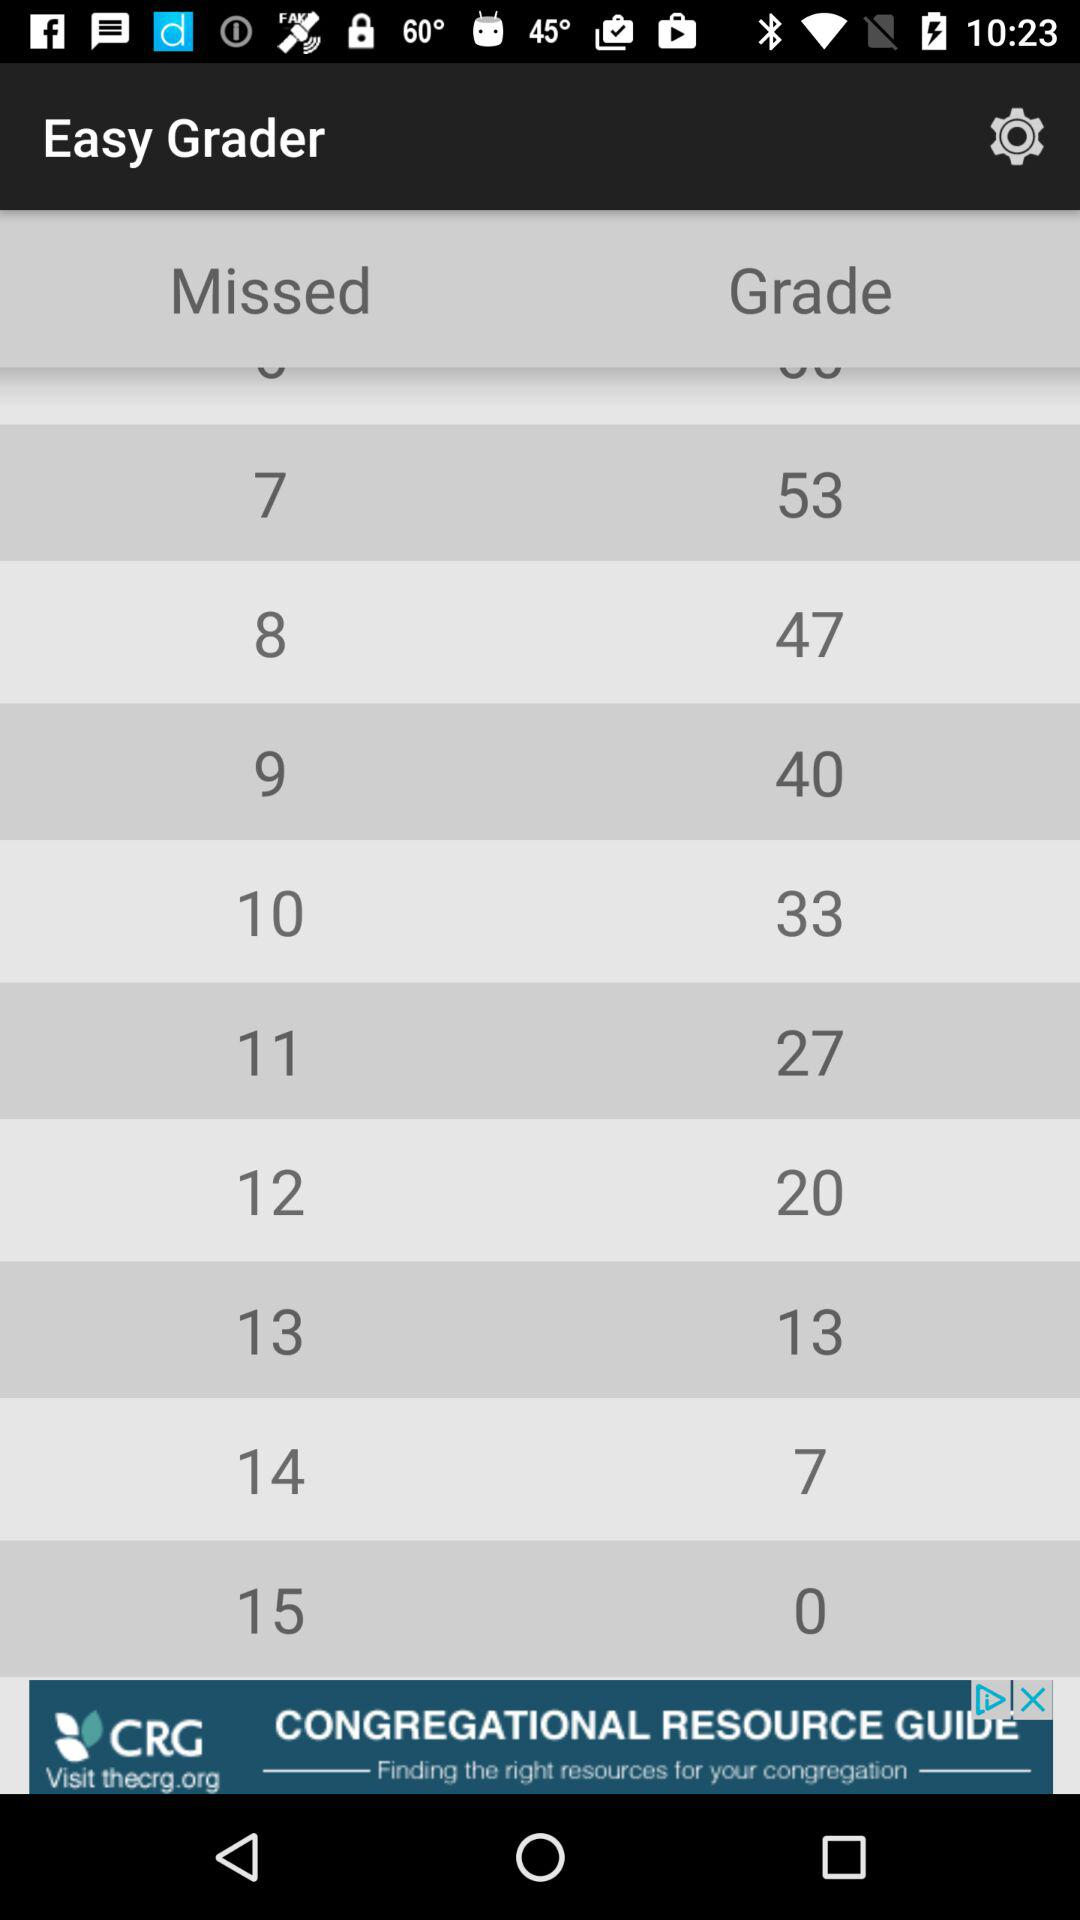What is the name of the application? The name of the application is "Easy Grader". 